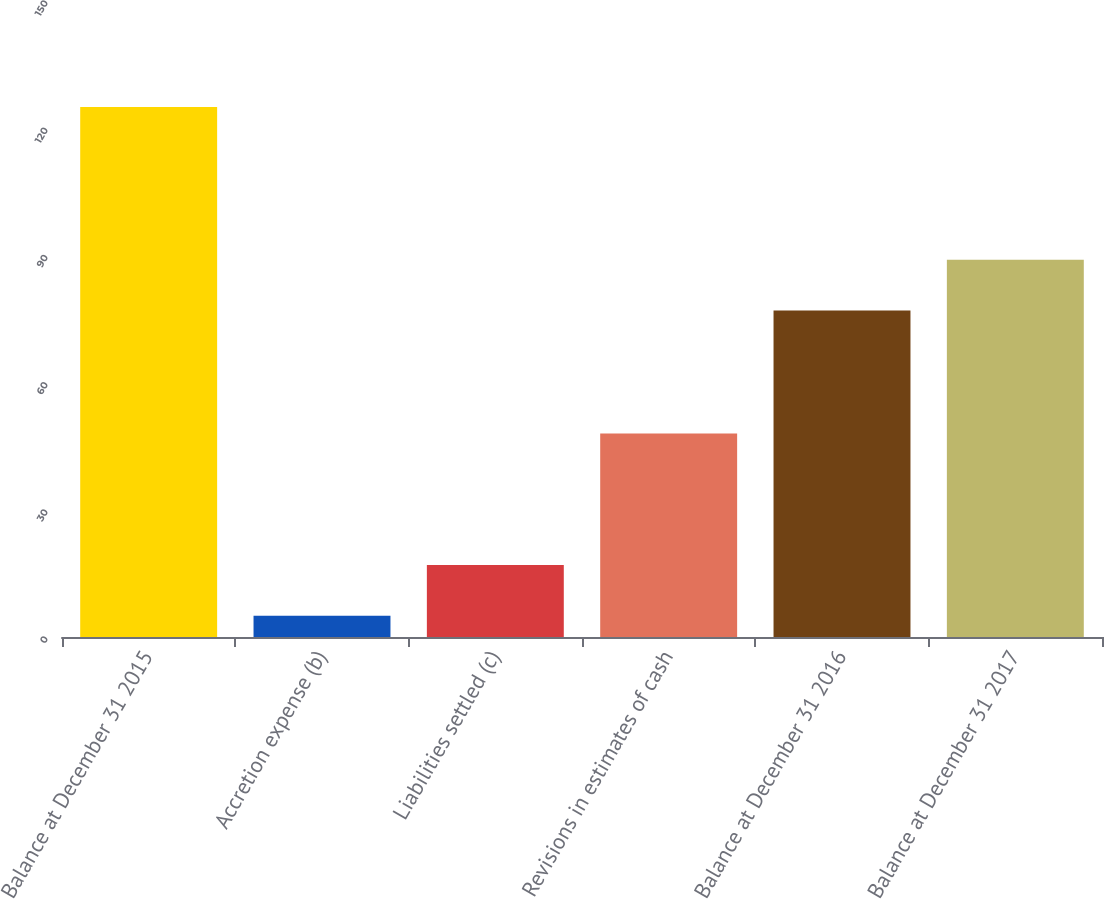Convert chart to OTSL. <chart><loc_0><loc_0><loc_500><loc_500><bar_chart><fcel>Balance at December 31 2015<fcel>Accretion expense (b)<fcel>Liabilities settled (c)<fcel>Revisions in estimates of cash<fcel>Balance at December 31 2016<fcel>Balance at December 31 2017<nl><fcel>125<fcel>5<fcel>17<fcel>48<fcel>77<fcel>89<nl></chart> 